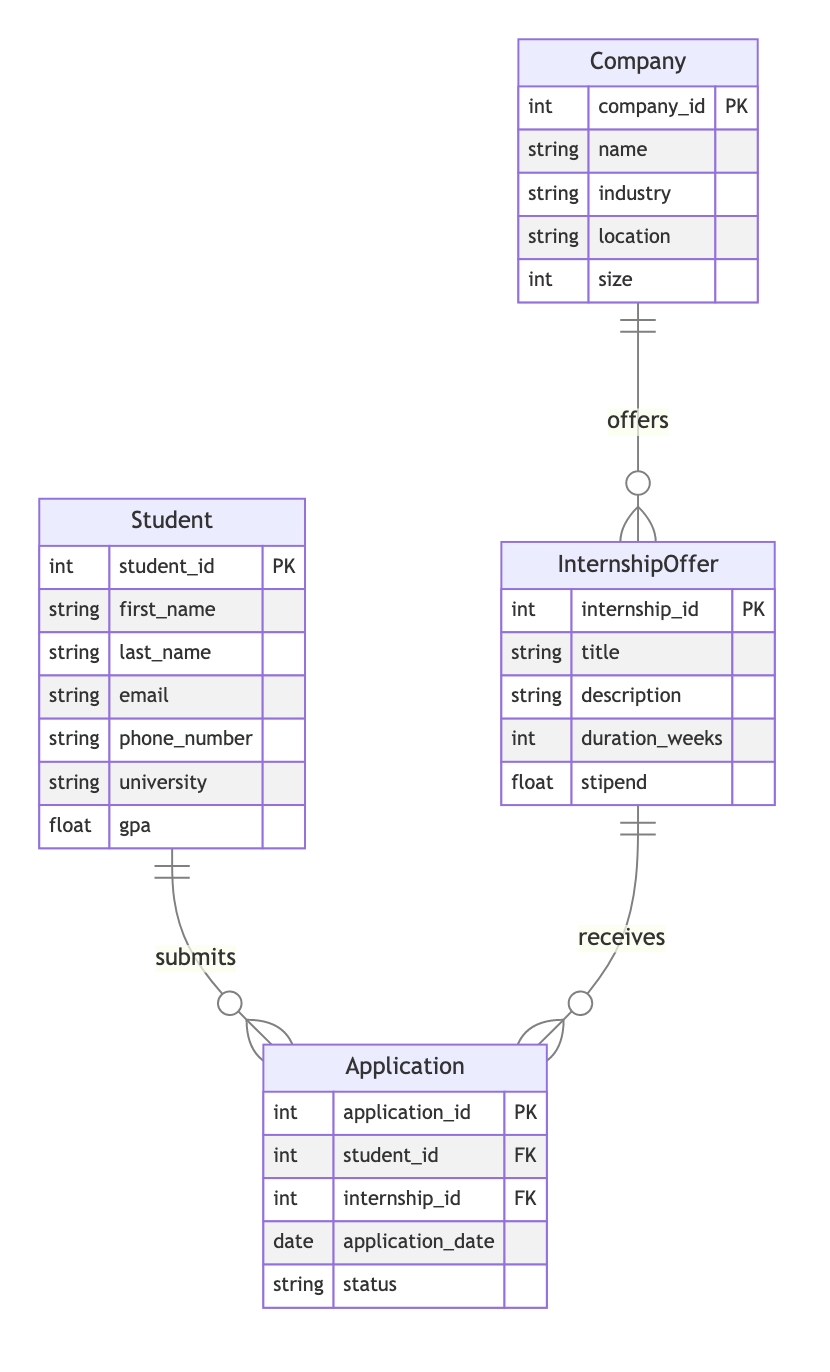What is the primary key of the Student entity? The primary key for the Student entity is "student_id," which uniquely identifies each student in this diagram.
Answer: student_id How many attributes does the Company entity have? The Company entity has five attributes: company_id, name, industry, location, and size. Counting these, we arrive at the total of five.
Answer: 5 What is the relationship type between Student and Application? The relationship type between the Student and Application entities is "submits," indicating a one-to-many relationship where each student can submit multiple applications.
Answer: one-to-many How many internship offers can a company provide? A company can provide multiple internship offers as indicated by the relationship "offers," which is a one-to-many relationship, meaning one company can have many corresponding internship offers.
Answer: many Which entity can directly access the attributes of the Application entity? The Application entity can be accessed directly by the Student and InternshipOffer entities, as they both connect through a one-to-many relationship to Application.
Answer: Student and InternshipOffer What does the "status" attribute in the Application entity indicate? The "status" attribute indicates the current state of the application, which can reflect whether it is pending, accepted, or rejected.
Answer: current state of the application How many entities are involved in the internship application process? There are four entities involved in this process: Student, InternshipOffer, Company, and Application. Counting these entities gives us a total of four.
Answer: 4 In the context of this diagram, what does the "applies_for" relationship represent? The "applies_for" relationship represents the connection between students and internship offers, indicating that students can apply for multiple internship offers.
Answer: connection between students and internship offers What attribute determines the duration of an internship offer? The "duration_weeks" attribute determines how long each internship offer lasts, measuring the length of the internship in weeks.
Answer: duration_weeks 